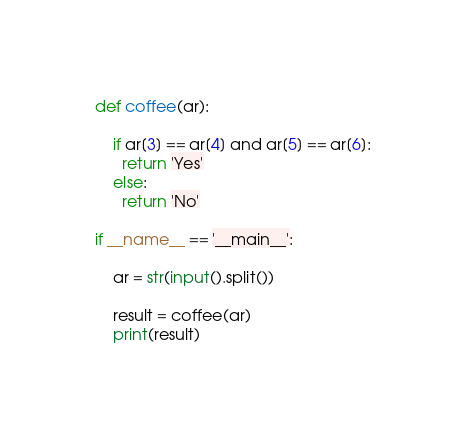Convert code to text. <code><loc_0><loc_0><loc_500><loc_500><_Python_>def coffee(ar):
    
    if ar[3] == ar[4] and ar[5] == ar[6]:
      return 'Yes'
    else:
      return 'No'

if __name__ == '__main__':

    ar = str(input().split())

    result = coffee(ar)
    print(result)</code> 